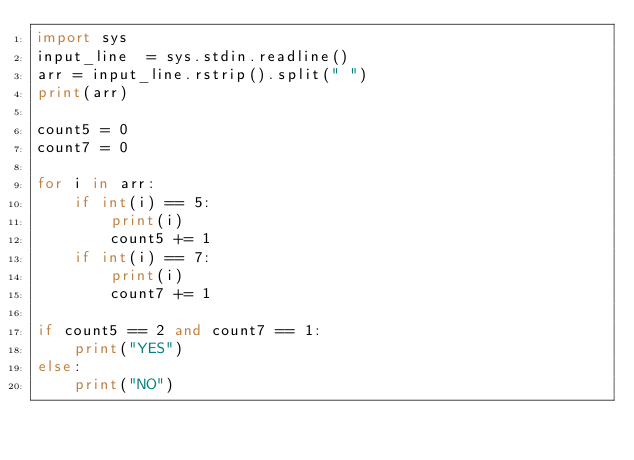<code> <loc_0><loc_0><loc_500><loc_500><_Python_>import sys
input_line  = sys.stdin.readline()
arr = input_line.rstrip().split(" ")
print(arr)

count5 = 0
count7 = 0

for i in arr:
    if int(i) == 5:
        print(i)
        count5 += 1
    if int(i) == 7:
        print(i)
        count7 += 1

if count5 == 2 and count7 == 1:
    print("YES")
else:
    print("NO")</code> 